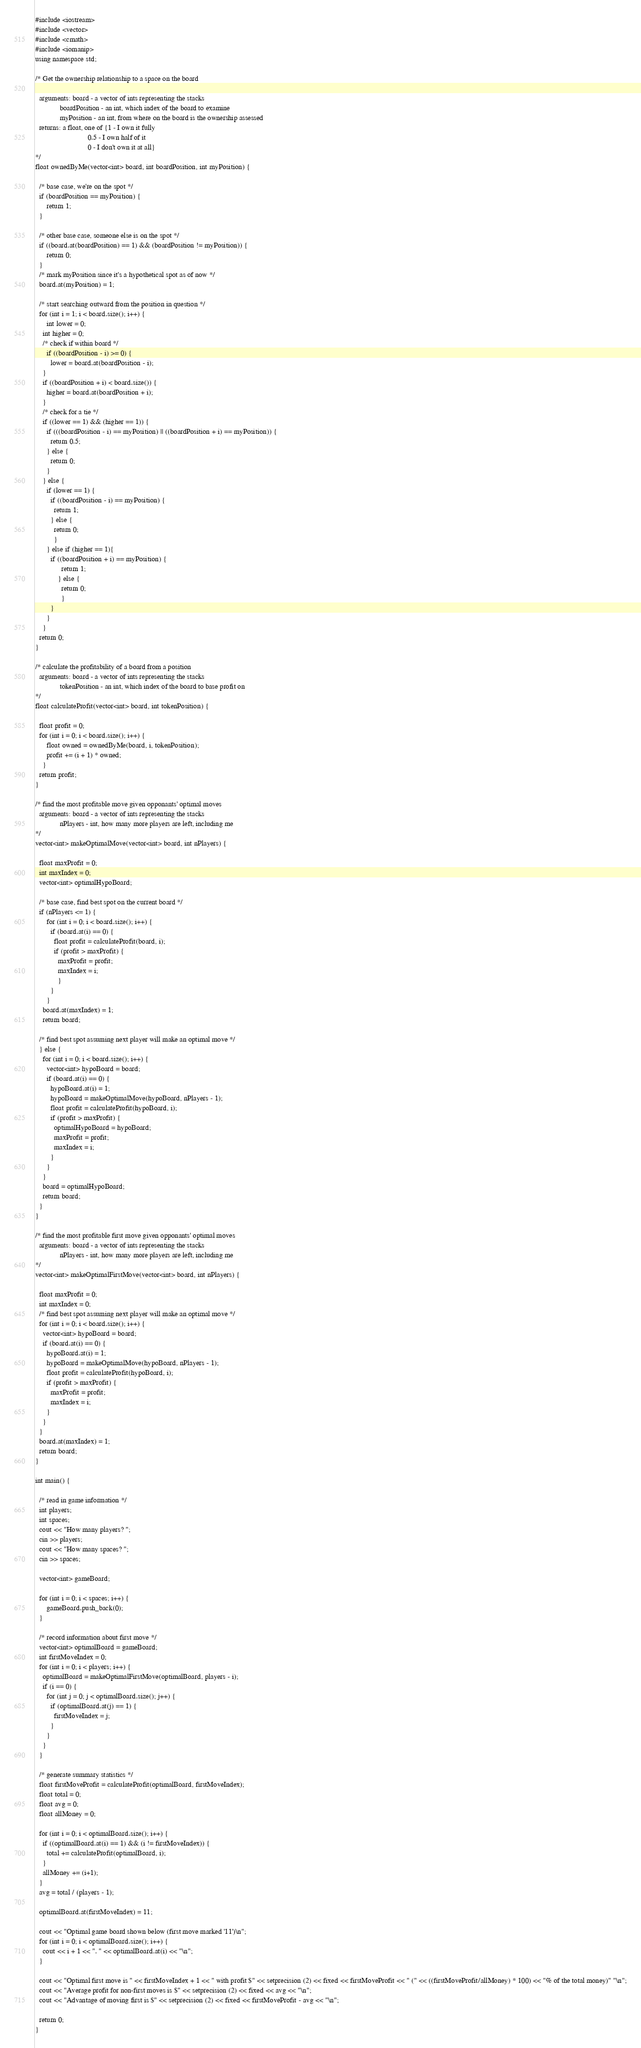Convert code to text. <code><loc_0><loc_0><loc_500><loc_500><_C++_>
#include <iostream>
#include <vector>
#include <cmath>
#include <iomanip>
using namespace std;

/* Get the ownership relationship to a space on the board

  arguments: board - a vector of ints representing the stacks
             boardPosition - an int, which index of the board to examine
             myPosition - an int, from where on the board is the ownership assessed
  returns: a float, one of {1 - I own it fully
                            0.5 - I own half of it
                            0 - I don't own it at all}
*/
float ownedByMe(vector<int> board, int boardPosition, int myPosition) {

  /* base case, we're on the spot */
  if (boardPosition == myPosition) {
	  return 1;
  }

  /* other base case, someone else is on the spot */
  if ((board.at(boardPosition) == 1) && (boardPosition != myPosition)) {
	  return 0;
  }
  /* mark myPosition since it's a hypothetical spot as of now */
  board.at(myPosition) = 1;

  /* start searching outward from the position in question */
  for (int i = 1; i < board.size(); i++) {
	  int lower = 0;
  	int higher = 0;
    /* check if within board */
	  if ((boardPosition - i) >= 0) {
	    lower = board.at(boardPosition - i);
  	}
  	if ((boardPosition + i) < board.size()) {
  	  higher = board.at(boardPosition + i);
  	}
  	/* check for a tie */
  	if ((lower == 1) && (higher == 1)) {
  	  if (((boardPosition - i) == myPosition) || ((boardPosition + i) == myPosition)) {
  	    return 0.5;
  	  } else {
  		return 0;
  	  }
  	} else {
  	  if (lower == 1) {
  		if ((boardPosition - i) == myPosition) {
  		  return 1;
  		} else {
  		  return 0;
  		  }
  	  } else if (higher == 1){
  		if ((boardPosition + i) == myPosition) {
    		  return 1;
    		} else {
    		  return 0;
    		  }
        }
  	  }
    }
  return 0;
}

/* calculate the profitability of a board from a position
  arguments: board - a vector of ints representing the stacks
             tokenPosition - an int, which index of the board to base profit on
*/
float calculateProfit(vector<int> board, int tokenPosition) {

  float profit = 0;
  for (int i = 0; i < board.size(); i++) {
	  float owned = ownedByMe(board, i, tokenPosition);
	  profit += (i + 1) * owned;
    }
  return profit;
}

/* find the most profitable move given opponants' optimal moves
  arguments: board - a vector of ints representing the stacks
             nPlayers - int, how many more players are left, including me
*/
vector<int> makeOptimalMove(vector<int> board, int nPlayers) {

  float maxProfit = 0;
  int maxIndex = 0;
  vector<int> optimalHypoBoard;

  /* base case, find best spot on the current board */
  if (nPlayers <= 1) {
	  for (int i = 0; i < board.size(); i++) {
	    if (board.at(i) == 0) {
	      float profit = calculateProfit(board, i);
	      if (profit > maxProfit) {
	        maxProfit = profit;
	  	    maxIndex = i;
	    	}
	    }
	  }
    board.at(maxIndex) = 1;
    return board;

  /* find best spot assuming next player will make an optimal move */
  } else {
    for (int i = 0; i < board.size(); i++) {
      vector<int> hypoBoard = board;
      if (board.at(i) == 0) {
        hypoBoard.at(i) = 1;
        hypoBoard = makeOptimalMove(hypoBoard, nPlayers - 1);
        float profit = calculateProfit(hypoBoard, i);
        if (profit > maxProfit) {
          optimalHypoBoard = hypoBoard;
          maxProfit = profit;
          maxIndex = i;
        }
      }
    }
    board = optimalHypoBoard;
    return board;
  }
}

/* find the most profitable first move given opponants' optimal moves
  arguments: board - a vector of ints representing the stacks
             nPlayers - int, how many more players are left, including me
*/
vector<int> makeOptimalFirstMove(vector<int> board, int nPlayers) {

  float maxProfit = 0;
  int maxIndex = 0;
  /* find best spot assuming next player will make an optimal move */
  for (int i = 0; i < board.size(); i++) {
    vector<int> hypoBoard = board;
    if (board.at(i) == 0) {
      hypoBoard.at(i) = 1;
      hypoBoard = makeOptimalMove(hypoBoard, nPlayers - 1);
      float profit = calculateProfit(hypoBoard, i);
      if (profit > maxProfit) {
        maxProfit = profit;
        maxIndex = i;
      }
    }
  }
  board.at(maxIndex) = 1;
  return board;
}

int main() {

  /* read in game information */
  int players;
  int spaces;
  cout << "How many players? ";
  cin >> players;
  cout << "How many spaces? ";
  cin >> spaces;

  vector<int> gameBoard;

  for (int i = 0; i < spaces; i++) {
	  gameBoard.push_back(0);
  }

  /* record information about first move */
  vector<int> optimalBoard = gameBoard;
  int firstMoveIndex = 0;
  for (int i = 0; i < players; i++) {
    optimalBoard = makeOptimalFirstMove(optimalBoard, players - i);
    if (i == 0) {
      for (int j = 0; j < optimalBoard.size(); j++) {
        if (optimalBoard.at(j) == 1) {
          firstMoveIndex = j;
        }
      }
    }
  }

  /* generate summary statistics */
  float firstMoveProfit = calculateProfit(optimalBoard, firstMoveIndex);
  float total = 0;
  float avg = 0;
  float allMoney = 0;

  for (int i = 0; i < optimalBoard.size(); i++) {
    if ((optimalBoard.at(i) == 1) && (i != firstMoveIndex)) {
      total += calculateProfit(optimalBoard, i);
    }
    allMoney += (i+1);
  }
  avg = total / (players - 1);

  optimalBoard.at(firstMoveIndex) = 11;

  cout << "Optimal game board shown below (first move marked '11')\n";
  for (int i = 0; i < optimalBoard.size(); i++) {
    cout << i + 1 << ". " << optimalBoard.at(i) << "\n";
  }

  cout << "Optimal first move is " << firstMoveIndex + 1 << " with profit $" << setprecision (2) << fixed << firstMoveProfit << " (" << ((firstMoveProfit/allMoney) * 100) << "% of the total money)" "\n";
  cout << "Average profit for non-first moves is $" << setprecision (2) << fixed << avg << "\n";
  cout << "Advantage of moving first is $" << setprecision (2) << fixed << firstMoveProfit - avg << "\n";

  return 0;
}
</code> 